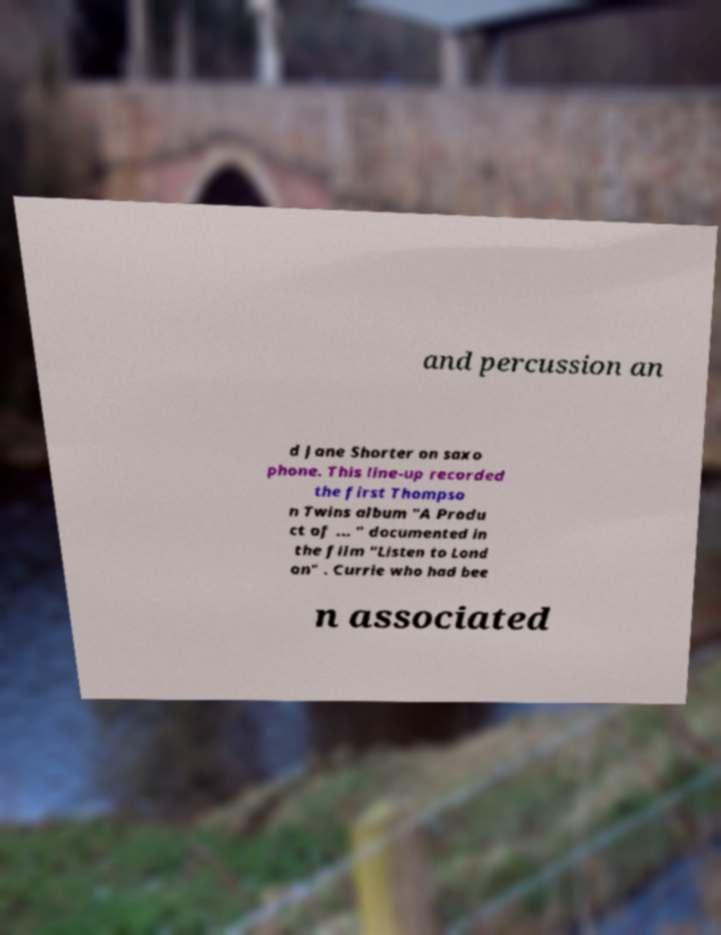For documentation purposes, I need the text within this image transcribed. Could you provide that? and percussion an d Jane Shorter on saxo phone. This line-up recorded the first Thompso n Twins album "A Produ ct of ... " documented in the film "Listen to Lond on" . Currie who had bee n associated 